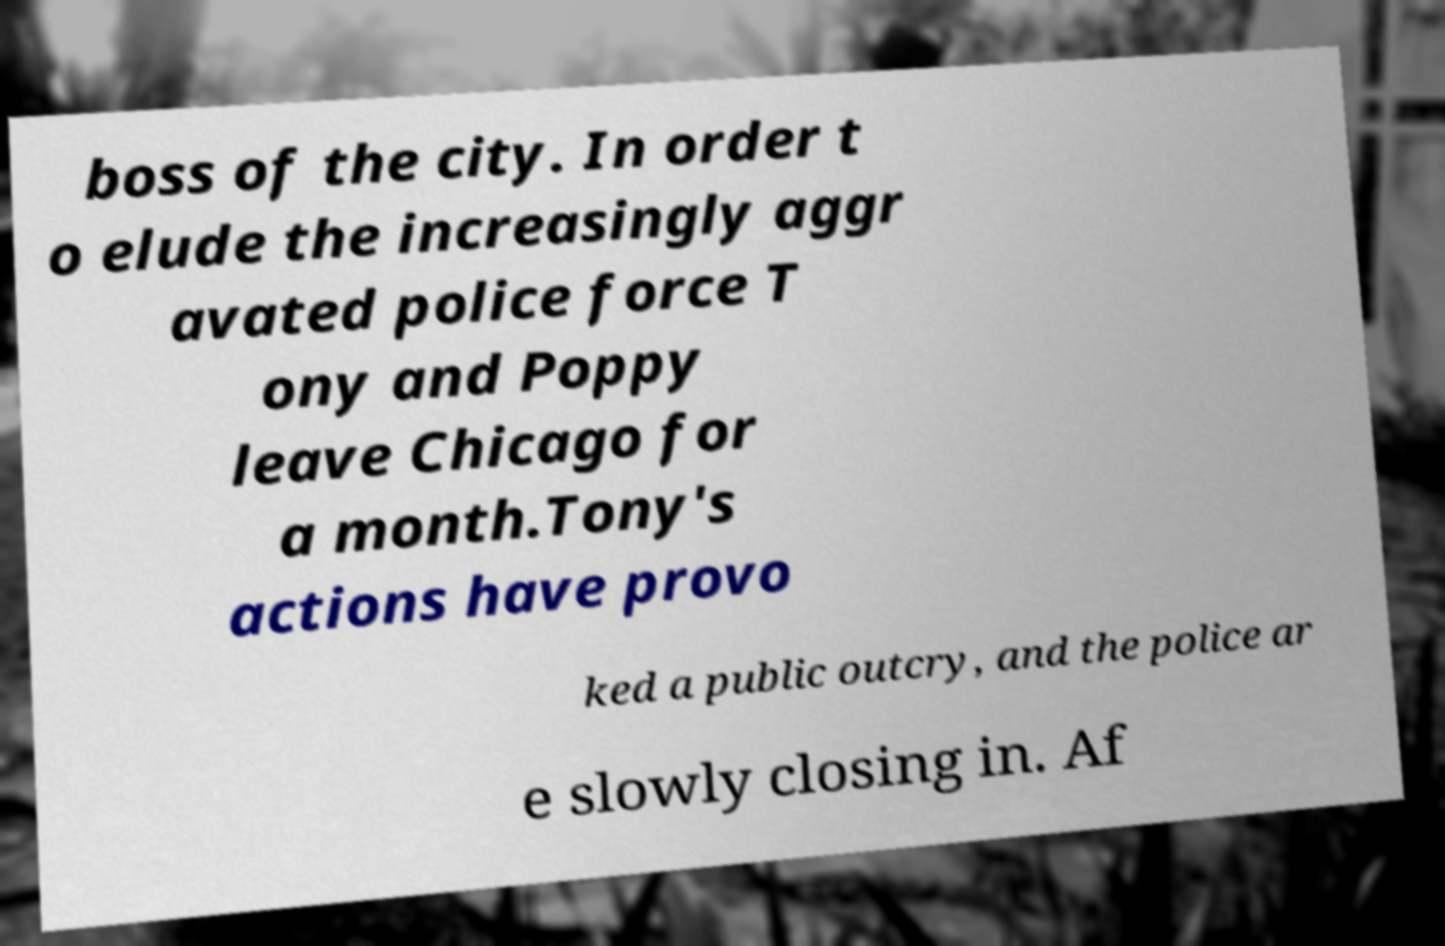There's text embedded in this image that I need extracted. Can you transcribe it verbatim? boss of the city. In order t o elude the increasingly aggr avated police force T ony and Poppy leave Chicago for a month.Tony's actions have provo ked a public outcry, and the police ar e slowly closing in. Af 